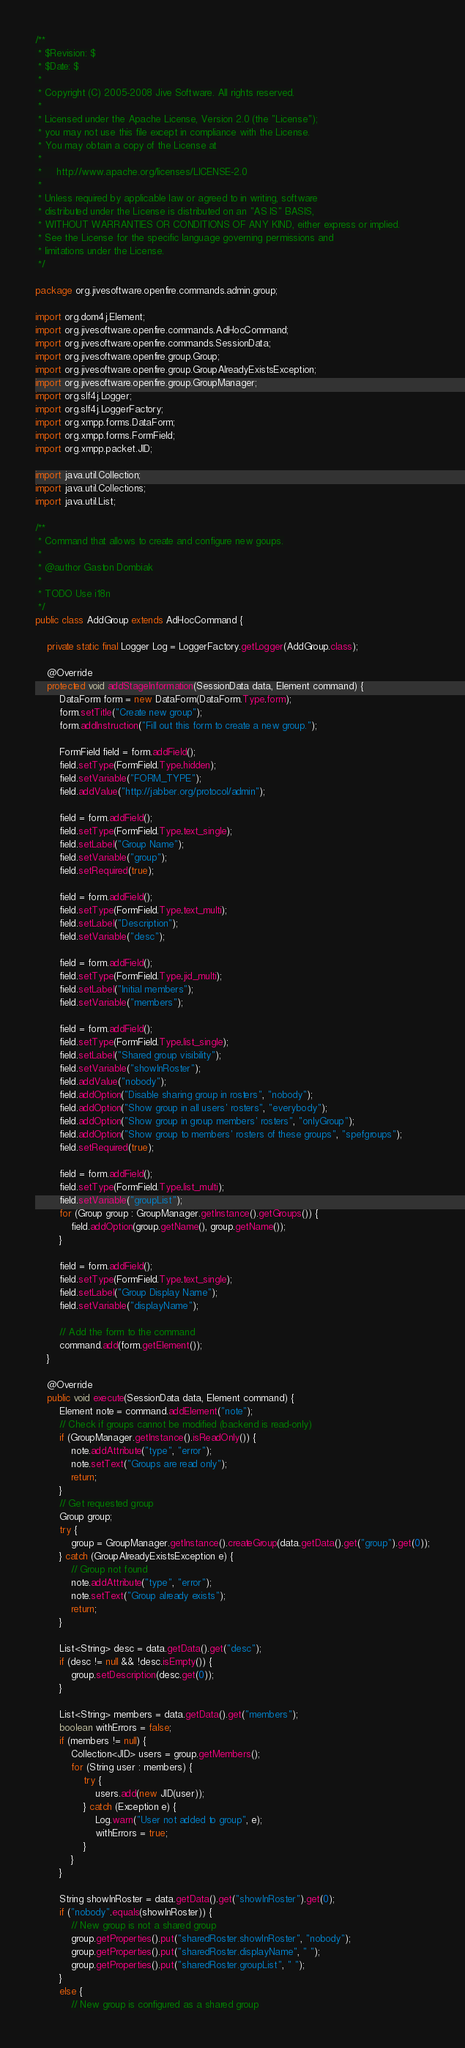Convert code to text. <code><loc_0><loc_0><loc_500><loc_500><_Java_>/**
 * $Revision: $
 * $Date: $
 *
 * Copyright (C) 2005-2008 Jive Software. All rights reserved.
 *
 * Licensed under the Apache License, Version 2.0 (the "License");
 * you may not use this file except in compliance with the License.
 * You may obtain a copy of the License at
 *
 *     http://www.apache.org/licenses/LICENSE-2.0
 *
 * Unless required by applicable law or agreed to in writing, software
 * distributed under the License is distributed on an "AS IS" BASIS,
 * WITHOUT WARRANTIES OR CONDITIONS OF ANY KIND, either express or implied.
 * See the License for the specific language governing permissions and
 * limitations under the License.
 */

package org.jivesoftware.openfire.commands.admin.group;

import org.dom4j.Element;
import org.jivesoftware.openfire.commands.AdHocCommand;
import org.jivesoftware.openfire.commands.SessionData;
import org.jivesoftware.openfire.group.Group;
import org.jivesoftware.openfire.group.GroupAlreadyExistsException;
import org.jivesoftware.openfire.group.GroupManager;
import org.slf4j.Logger;
import org.slf4j.LoggerFactory;
import org.xmpp.forms.DataForm;
import org.xmpp.forms.FormField;
import org.xmpp.packet.JID;

import java.util.Collection;
import java.util.Collections;
import java.util.List;

/**
 * Command that allows to create and configure new goups.
 *
 * @author Gaston Dombiak
 *
 * TODO Use i18n
 */
public class AddGroup extends AdHocCommand {
	
	private static final Logger Log = LoggerFactory.getLogger(AddGroup.class);

    @Override
	protected void addStageInformation(SessionData data, Element command) {
        DataForm form = new DataForm(DataForm.Type.form);
        form.setTitle("Create new group");
        form.addInstruction("Fill out this form to create a new group.");

        FormField field = form.addField();
        field.setType(FormField.Type.hidden);
        field.setVariable("FORM_TYPE");
        field.addValue("http://jabber.org/protocol/admin");

        field = form.addField();
        field.setType(FormField.Type.text_single);
        field.setLabel("Group Name");
        field.setVariable("group");
        field.setRequired(true);

        field = form.addField();
        field.setType(FormField.Type.text_multi);
        field.setLabel("Description");
        field.setVariable("desc");

        field = form.addField();
        field.setType(FormField.Type.jid_multi);
        field.setLabel("Initial members");
        field.setVariable("members");

        field = form.addField();
        field.setType(FormField.Type.list_single);
        field.setLabel("Shared group visibility");
        field.setVariable("showInRoster");
        field.addValue("nobody");
        field.addOption("Disable sharing group in rosters", "nobody");
        field.addOption("Show group in all users' rosters", "everybody");
        field.addOption("Show group in group members' rosters", "onlyGroup");
        field.addOption("Show group to members' rosters of these groups", "spefgroups");
        field.setRequired(true);

        field = form.addField();
        field.setType(FormField.Type.list_multi);
        field.setVariable("groupList");
        for (Group group : GroupManager.getInstance().getGroups()) {
            field.addOption(group.getName(), group.getName());
        }

        field = form.addField();
        field.setType(FormField.Type.text_single);
        field.setLabel("Group Display Name");
        field.setVariable("displayName");

        // Add the form to the command
        command.add(form.getElement());
    }

    @Override
	public void execute(SessionData data, Element command) {
        Element note = command.addElement("note");
        // Check if groups cannot be modified (backend is read-only)
        if (GroupManager.getInstance().isReadOnly()) {
            note.addAttribute("type", "error");
            note.setText("Groups are read only");
            return;
        }
        // Get requested group
        Group group;
        try {
            group = GroupManager.getInstance().createGroup(data.getData().get("group").get(0));
        } catch (GroupAlreadyExistsException e) {
            // Group not found
            note.addAttribute("type", "error");
            note.setText("Group already exists");
            return;
        }

        List<String> desc = data.getData().get("desc");
        if (desc != null && !desc.isEmpty()) {
            group.setDescription(desc.get(0));
        }

        List<String> members = data.getData().get("members");
        boolean withErrors = false;
        if (members != null) {
            Collection<JID> users = group.getMembers();
            for (String user : members) {
                try {
                    users.add(new JID(user));
                } catch (Exception e) {
                    Log.warn("User not added to group", e);
                    withErrors = true;
                }
            }
        }

        String showInRoster = data.getData().get("showInRoster").get(0);
        if ("nobody".equals(showInRoster)) {
            // New group is not a shared group
            group.getProperties().put("sharedRoster.showInRoster", "nobody");
            group.getProperties().put("sharedRoster.displayName", " ");
            group.getProperties().put("sharedRoster.groupList", " ");
        }
        else {
            // New group is configured as a shared group</code> 